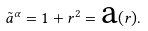<formula> <loc_0><loc_0><loc_500><loc_500>\tilde { a } ^ { \alpha } = 1 + r ^ { 2 } = { \text {a} } ( r ) .</formula> 